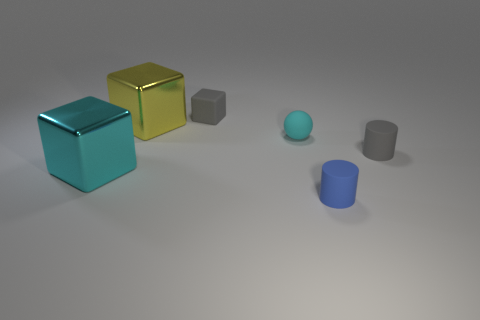There is a gray thing in front of the tiny gray cube; are there any small cyan things that are in front of it?
Your answer should be very brief. No. What number of cubes are either big brown rubber objects or gray things?
Your response must be concise. 1. Are there any other cyan shiny things of the same shape as the cyan metallic thing?
Provide a succinct answer. No. The tiny cyan matte thing has what shape?
Offer a terse response. Sphere. What number of things are either tiny gray cylinders or big cyan objects?
Provide a succinct answer. 2. Is the size of the gray rubber thing that is on the right side of the small blue object the same as the cyan metallic cube that is behind the blue matte cylinder?
Keep it short and to the point. No. How many other things are there of the same material as the tiny gray cube?
Your answer should be compact. 3. Is the number of cyan shiny things that are on the right side of the gray cylinder greater than the number of blue matte objects behind the large yellow shiny thing?
Your answer should be compact. No. There is a small cylinder in front of the big cyan metal thing; what is it made of?
Make the answer very short. Rubber. Does the blue object have the same shape as the cyan matte object?
Your answer should be very brief. No. 